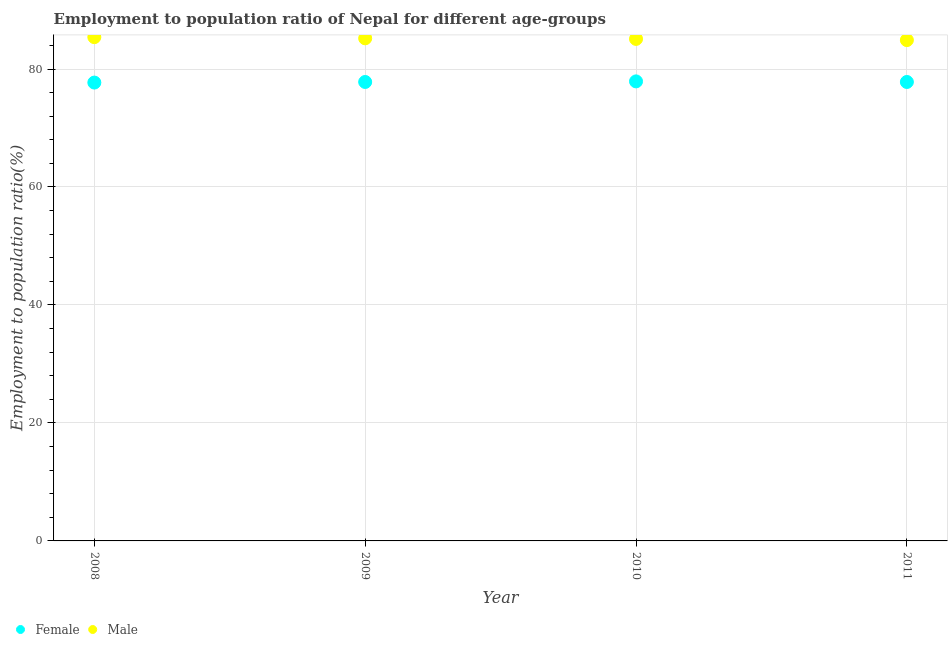How many different coloured dotlines are there?
Your answer should be very brief. 2. Is the number of dotlines equal to the number of legend labels?
Ensure brevity in your answer.  Yes. What is the employment to population ratio(female) in 2009?
Ensure brevity in your answer.  77.8. Across all years, what is the maximum employment to population ratio(male)?
Your answer should be compact. 85.4. Across all years, what is the minimum employment to population ratio(male)?
Offer a very short reply. 84.9. What is the total employment to population ratio(male) in the graph?
Provide a succinct answer. 340.6. What is the difference between the employment to population ratio(female) in 2010 and that in 2011?
Keep it short and to the point. 0.1. What is the difference between the employment to population ratio(female) in 2011 and the employment to population ratio(male) in 2008?
Your response must be concise. -7.6. What is the average employment to population ratio(male) per year?
Your answer should be very brief. 85.15. In the year 2011, what is the difference between the employment to population ratio(female) and employment to population ratio(male)?
Provide a short and direct response. -7.1. What is the ratio of the employment to population ratio(male) in 2009 to that in 2011?
Your answer should be compact. 1. Is the employment to population ratio(female) in 2010 less than that in 2011?
Provide a short and direct response. No. Is the difference between the employment to population ratio(male) in 2010 and 2011 greater than the difference between the employment to population ratio(female) in 2010 and 2011?
Your answer should be very brief. Yes. What is the difference between the highest and the second highest employment to population ratio(male)?
Your response must be concise. 0.2. What is the difference between the highest and the lowest employment to population ratio(female)?
Offer a very short reply. 0.2. Is the employment to population ratio(male) strictly greater than the employment to population ratio(female) over the years?
Your answer should be compact. Yes. What is the difference between two consecutive major ticks on the Y-axis?
Offer a very short reply. 20. Where does the legend appear in the graph?
Provide a succinct answer. Bottom left. What is the title of the graph?
Keep it short and to the point. Employment to population ratio of Nepal for different age-groups. What is the label or title of the X-axis?
Give a very brief answer. Year. What is the label or title of the Y-axis?
Your answer should be compact. Employment to population ratio(%). What is the Employment to population ratio(%) in Female in 2008?
Your answer should be compact. 77.7. What is the Employment to population ratio(%) of Male in 2008?
Your response must be concise. 85.4. What is the Employment to population ratio(%) in Female in 2009?
Ensure brevity in your answer.  77.8. What is the Employment to population ratio(%) of Male in 2009?
Your answer should be compact. 85.2. What is the Employment to population ratio(%) in Female in 2010?
Make the answer very short. 77.9. What is the Employment to population ratio(%) of Male in 2010?
Your response must be concise. 85.1. What is the Employment to population ratio(%) in Female in 2011?
Provide a succinct answer. 77.8. What is the Employment to population ratio(%) in Male in 2011?
Offer a very short reply. 84.9. Across all years, what is the maximum Employment to population ratio(%) in Female?
Your answer should be compact. 77.9. Across all years, what is the maximum Employment to population ratio(%) of Male?
Your answer should be compact. 85.4. Across all years, what is the minimum Employment to population ratio(%) in Female?
Your answer should be very brief. 77.7. Across all years, what is the minimum Employment to population ratio(%) in Male?
Provide a succinct answer. 84.9. What is the total Employment to population ratio(%) in Female in the graph?
Ensure brevity in your answer.  311.2. What is the total Employment to population ratio(%) in Male in the graph?
Your answer should be very brief. 340.6. What is the difference between the Employment to population ratio(%) in Female in 2008 and that in 2011?
Provide a succinct answer. -0.1. What is the difference between the Employment to population ratio(%) in Male in 2008 and that in 2011?
Your answer should be compact. 0.5. What is the difference between the Employment to population ratio(%) of Female in 2009 and that in 2010?
Make the answer very short. -0.1. What is the difference between the Employment to population ratio(%) in Male in 2009 and that in 2010?
Provide a succinct answer. 0.1. What is the difference between the Employment to population ratio(%) in Male in 2009 and that in 2011?
Make the answer very short. 0.3. What is the difference between the Employment to population ratio(%) in Female in 2008 and the Employment to population ratio(%) in Male in 2010?
Make the answer very short. -7.4. What is the difference between the Employment to population ratio(%) in Female in 2009 and the Employment to population ratio(%) in Male in 2010?
Keep it short and to the point. -7.3. What is the difference between the Employment to population ratio(%) in Female in 2010 and the Employment to population ratio(%) in Male in 2011?
Offer a terse response. -7. What is the average Employment to population ratio(%) in Female per year?
Provide a short and direct response. 77.8. What is the average Employment to population ratio(%) of Male per year?
Make the answer very short. 85.15. What is the ratio of the Employment to population ratio(%) of Female in 2008 to that in 2010?
Your response must be concise. 1. What is the ratio of the Employment to population ratio(%) of Male in 2008 to that in 2011?
Ensure brevity in your answer.  1.01. What is the ratio of the Employment to population ratio(%) of Female in 2009 to that in 2010?
Keep it short and to the point. 1. What is the ratio of the Employment to population ratio(%) of Male in 2009 to that in 2010?
Make the answer very short. 1. What is the ratio of the Employment to population ratio(%) in Female in 2009 to that in 2011?
Provide a succinct answer. 1. What is the ratio of the Employment to population ratio(%) of Male in 2010 to that in 2011?
Ensure brevity in your answer.  1. What is the difference between the highest and the second highest Employment to population ratio(%) in Female?
Give a very brief answer. 0.1. What is the difference between the highest and the lowest Employment to population ratio(%) of Female?
Your response must be concise. 0.2. What is the difference between the highest and the lowest Employment to population ratio(%) of Male?
Offer a terse response. 0.5. 